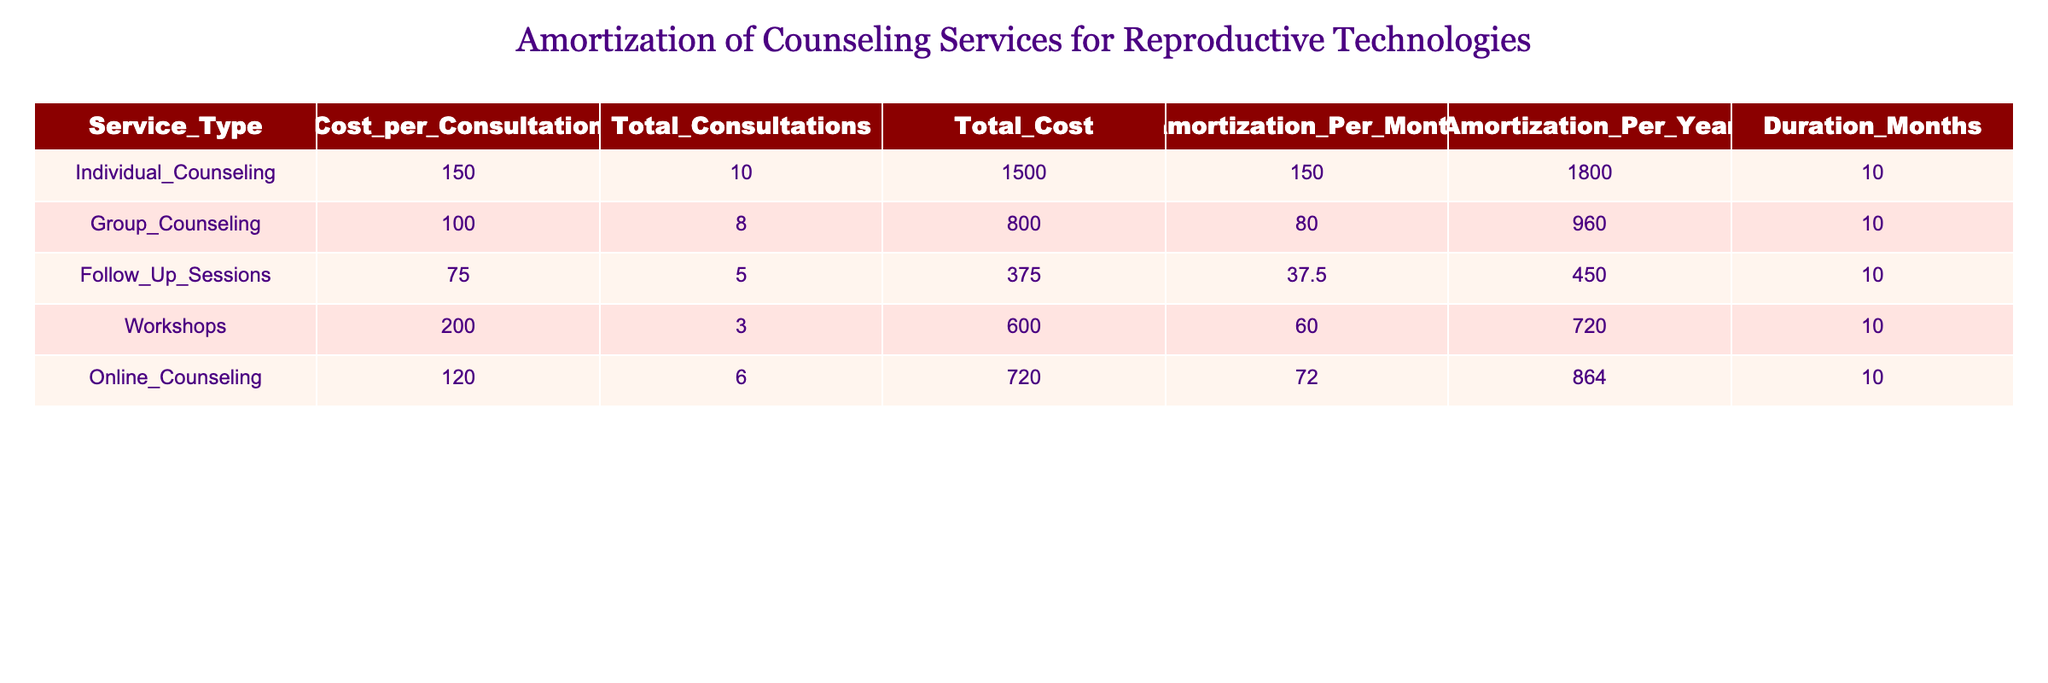What is the total cost of individual counseling? The total cost for individual counseling is listed in the "Total_Cost" column, which shows the value as 1500.
Answer: 1500 How many consultations are scheduled for group counseling? The total consultations for group counseling can be found in the "Total_Consultations" column, which lists the value as 8.
Answer: 8 Is the amortization per month for follow-up sessions greater than that for individual counseling? The amortization per month for follow-up sessions is 37.5 and for individual counseling is 150. Since 37.5 is not greater than 150, the answer is no.
Answer: No What is the total amortization for workshops over the entire duration? The total amortization per year for workshops is 720, and the duration is 10 months. We calculate by dividing the total duration by 12 months and multiplying by the annual amortization: (10/12) * 720 = 600.
Answer: 600 What is the combined total cost of online counseling and follow-up sessions? To find this, we sum the total cost of online counseling (720) and follow-up sessions (375): 720 + 375 = 1095.
Answer: 1095 What is the average cost per consultation across all service types? First, calculate the total cost for all services: 1500 + 800 + 375 + 600 + 720 = 3995. Then, find the total number of consultations: 10 + 8 + 5 + 3 + 6 = 32. The average is calculated by dividing the total cost by the number of consultations: 3995 / 32 = 124.84.
Answer: 124.84 Are there more sessions planned for individual counseling compared to workshops? Individual counseling has 10 total consultations while workshops have 3. Since 10 is greater than 3, the answer to the comparison is yes.
Answer: Yes What is the total amortization amount across all counseling services per month? To calculate the total amortization per month, we sum the individual amortizations per month: 150 + 80 + 37.5 + 60 + 72 = 399.5.
Answer: 399.5 What is the service type with the highest total cost and what is that cost? From the "Total_Cost" column, individual counseling has the highest total cost at 1500.
Answer: 1500 